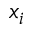Convert formula to latex. <formula><loc_0><loc_0><loc_500><loc_500>x _ { i }</formula> 